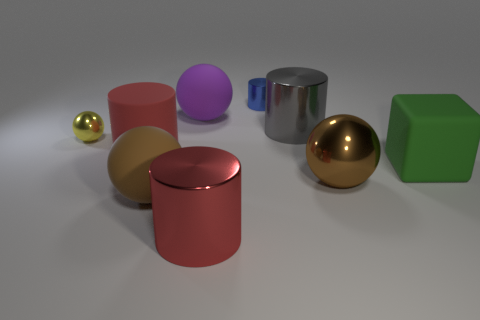Are there any patterns or repetitions in the arrangement of these objects? While there are no explicit patterns or repetitions in the arrangement of the objects, there is a symmetrical setup in terms of shapes. For example, there are two spheres and two cylinders. However, the arrangement does not seem to follow any particular order or sequence. 